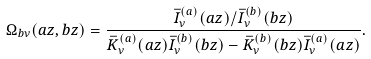<formula> <loc_0><loc_0><loc_500><loc_500>\Omega _ { b \nu } ( a z , b z ) = \frac { \bar { I } _ { \nu } ^ { ( a ) } ( a z ) / \bar { I } _ { \nu } ^ { ( b ) } ( b z ) } { \bar { K } _ { \nu } ^ { ( a ) } ( a z ) \bar { I } _ { \nu } ^ { ( b ) } ( b z ) - \bar { K } _ { \nu } ^ { ( b ) } ( b z ) \bar { I } _ { \nu } ^ { ( a ) } ( a z ) } .</formula> 